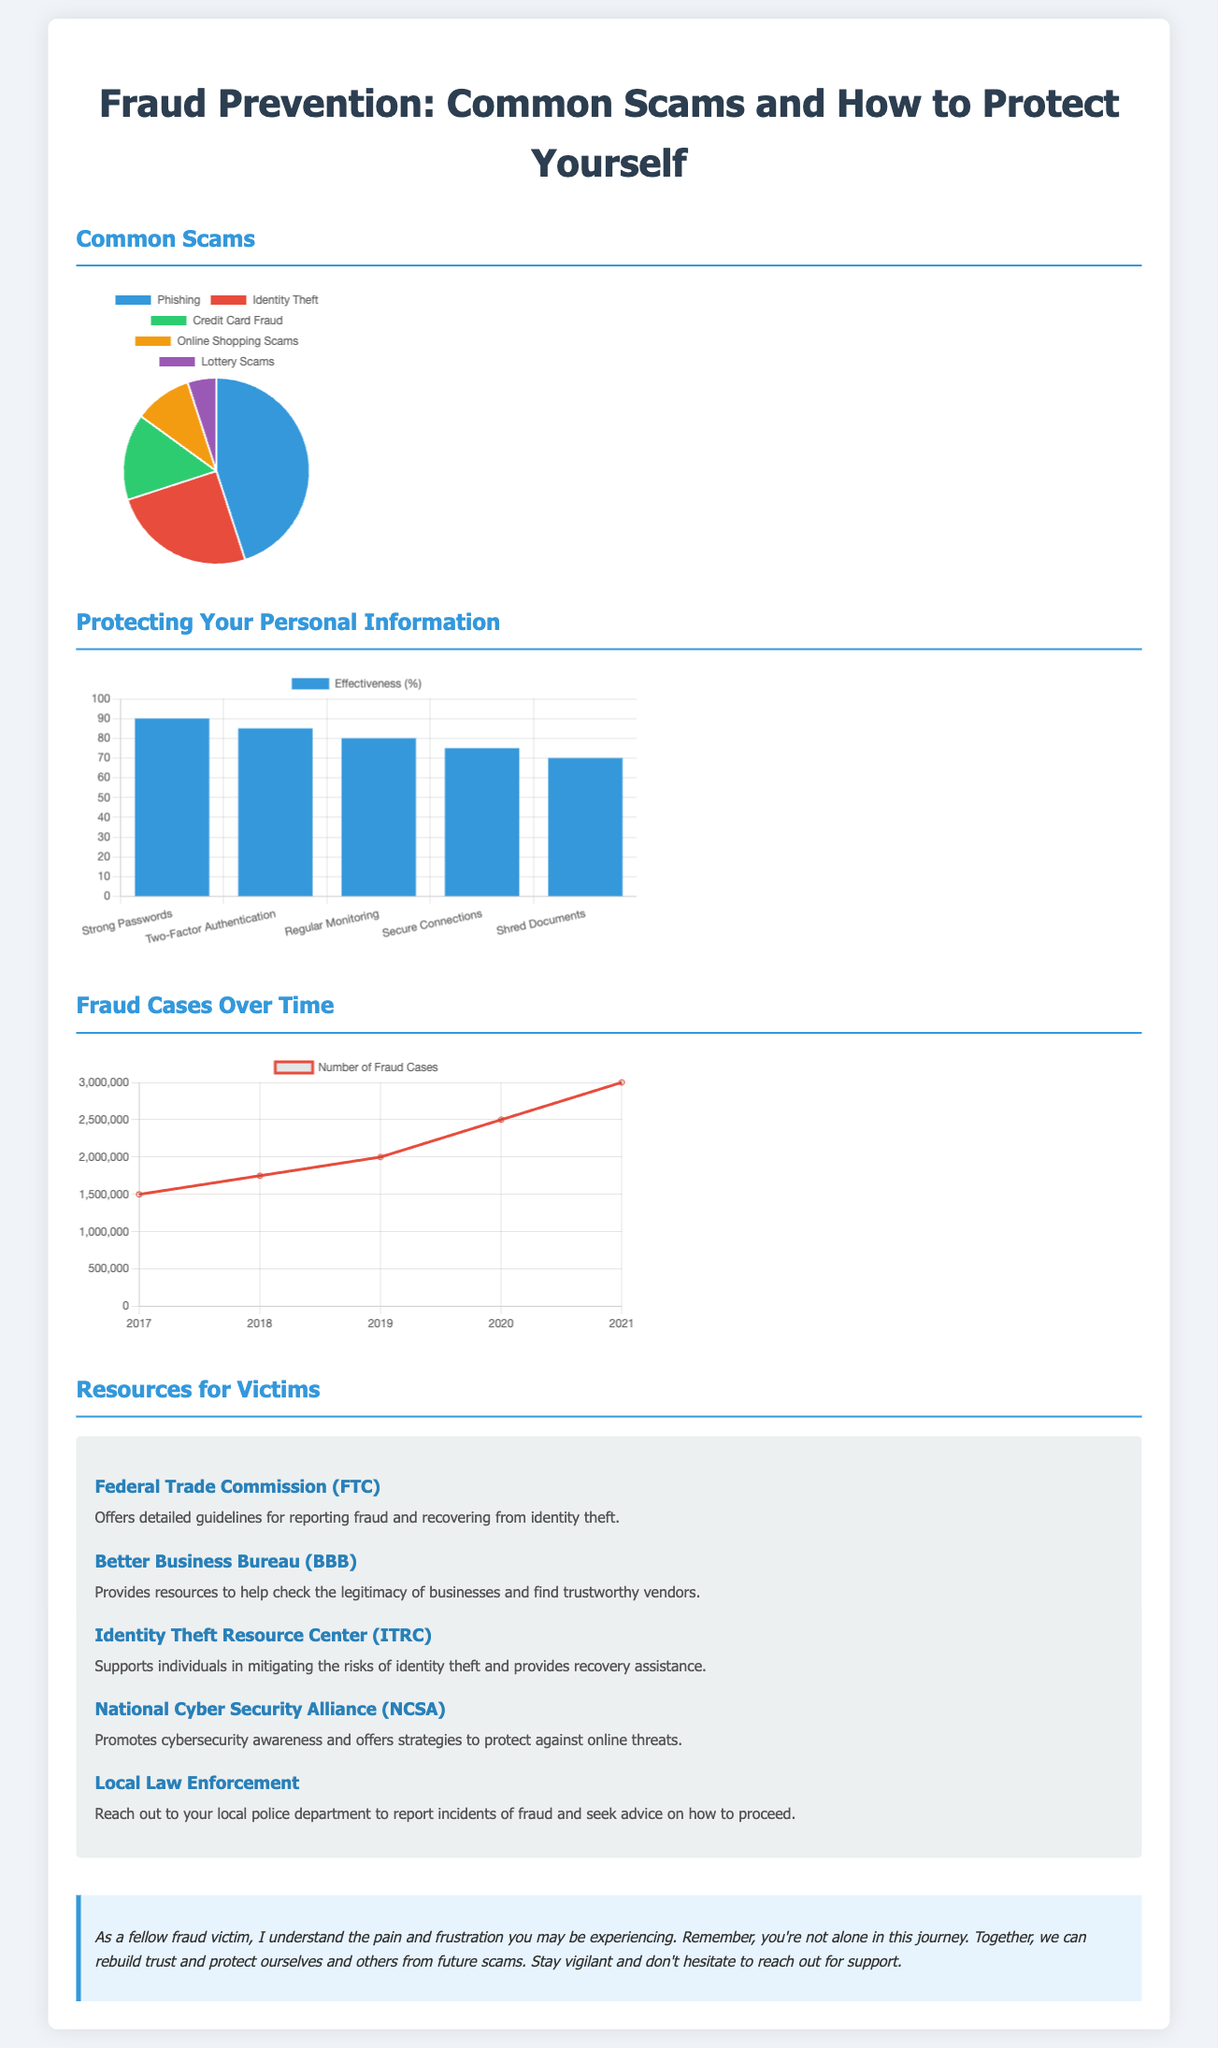what are the top two common scams? The chart shows the two most common scams based on distribution: Phishing and Identity Theft.
Answer: Phishing, Identity Theft what percentage of fraud cases occurred in 2021? The line chart indicates the number of fraud cases for the year 2021 specifically.
Answer: 3000000 which protection method has the highest effectiveness? The bar chart displays the effectiveness percentage for various protection methods, identifying the one with the highest score.
Answer: Strong Passwords how many total types of scams are represented in the chart? The pie chart illustrates the distribution of five distinct types of scams.
Answer: Five who can one contact for identity theft recovery assistance? The document lists resources for victims, specifically those offering recovery assistance for identity theft.
Answer: Identity Theft Resource Center what year saw the lowest number of fraud cases? The line chart details fraud case numbers year by year, indicating the year with the least cases.
Answer: 2017 which method has an effectiveness of 85%? The bar chart details the effectiveness of various protection methods, allowing us to identify the relevant one.
Answer: Two-Factor Authentication how many resources for victims are listed in the document? The resource section contains several organizations that support fraud victims, specifying the total number of resources.
Answer: Five 